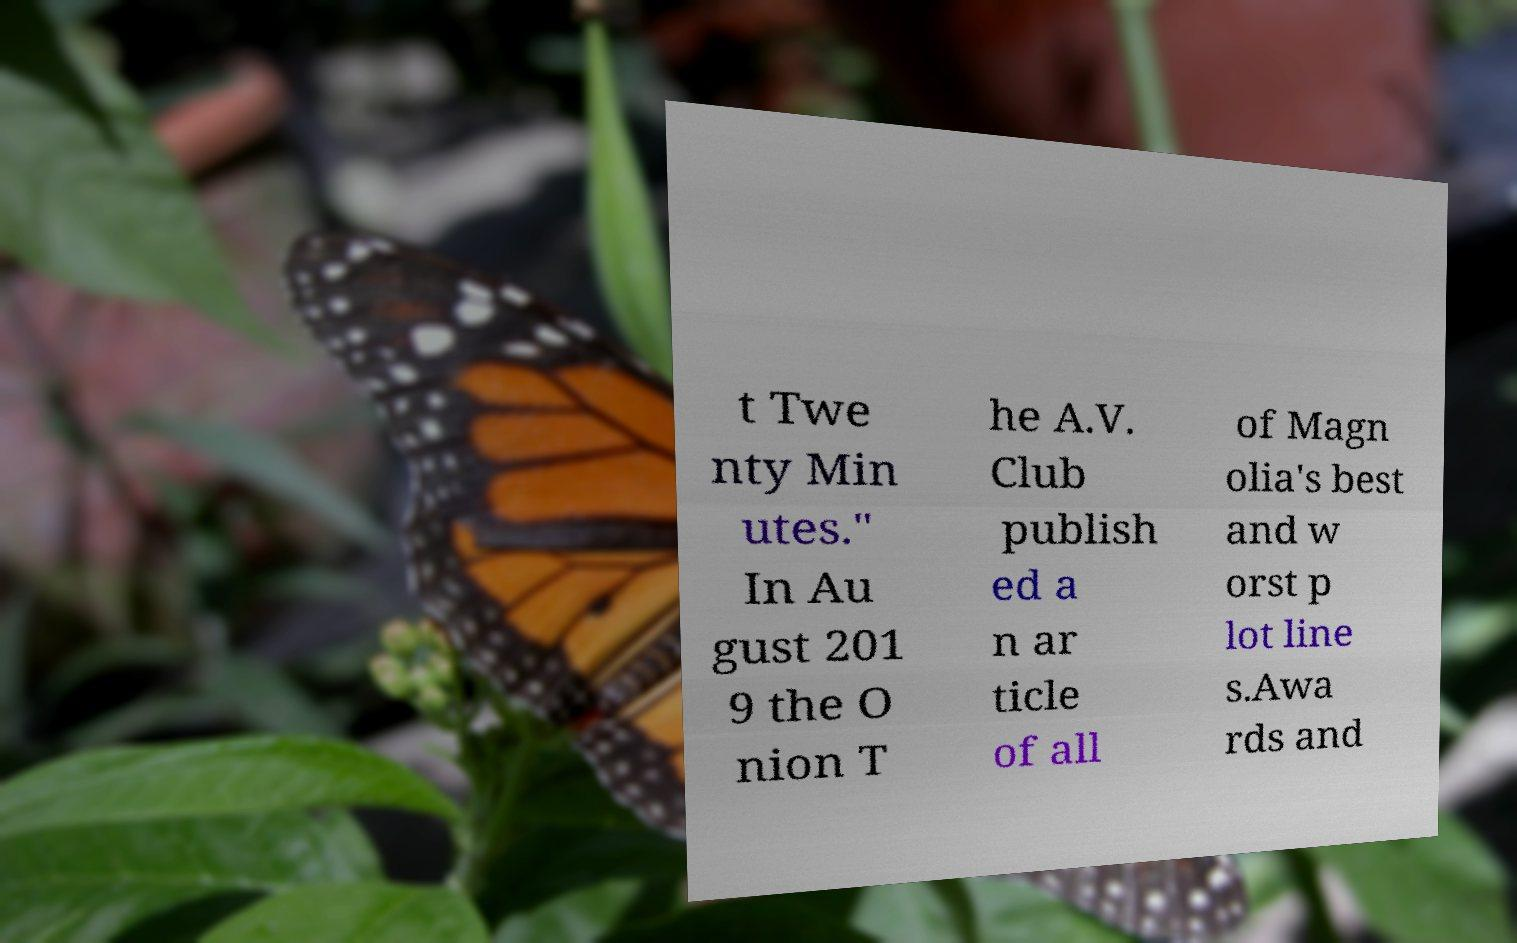There's text embedded in this image that I need extracted. Can you transcribe it verbatim? t Twe nty Min utes." In Au gust 201 9 the O nion T he A.V. Club publish ed a n ar ticle of all of Magn olia's best and w orst p lot line s.Awa rds and 